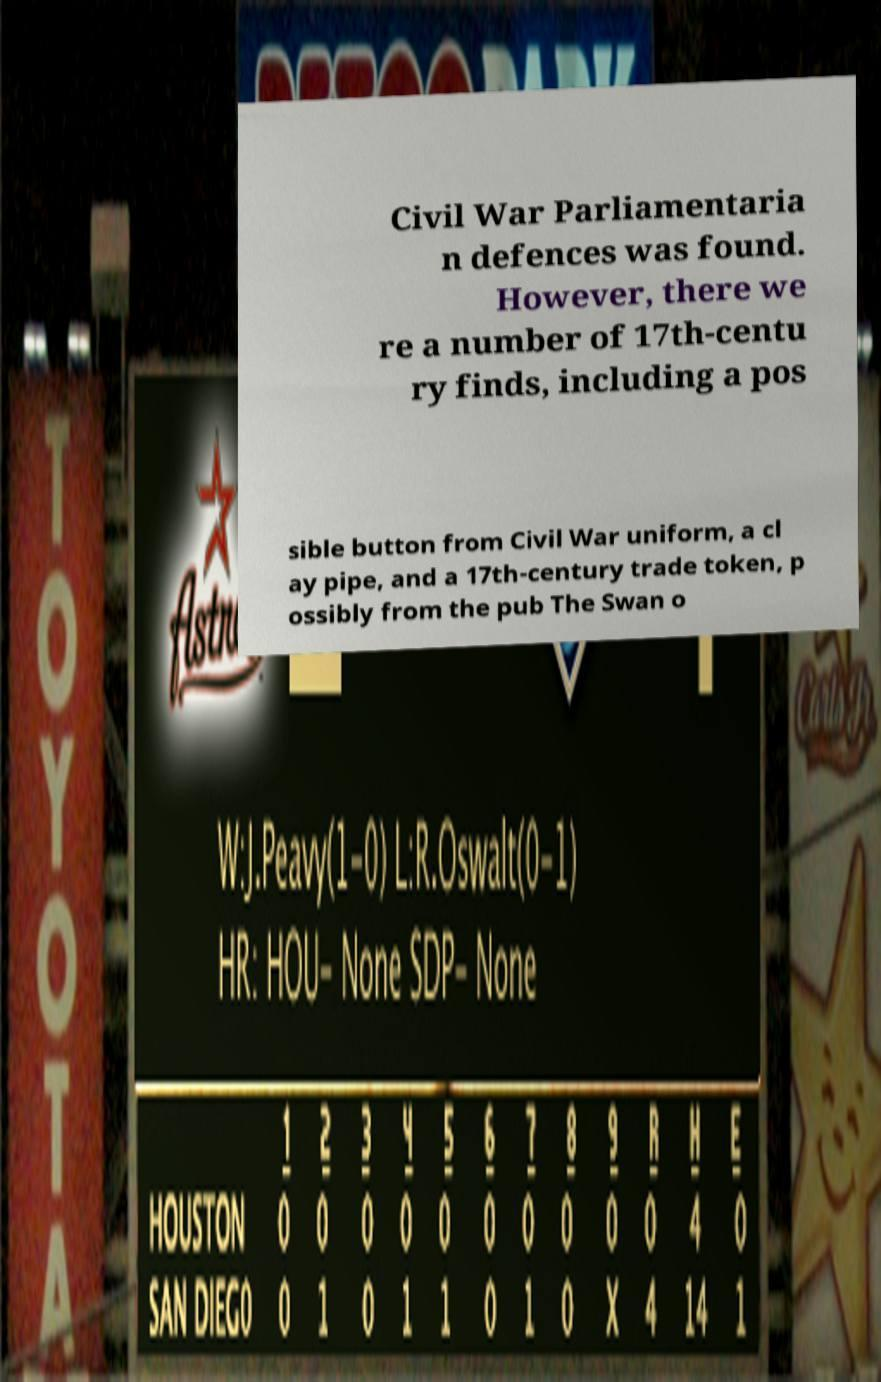What messages or text are displayed in this image? I need them in a readable, typed format. Civil War Parliamentaria n defences was found. However, there we re a number of 17th-centu ry finds, including a pos sible button from Civil War uniform, a cl ay pipe, and a 17th-century trade token, p ossibly from the pub The Swan o 